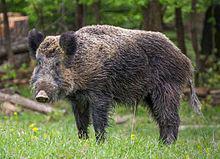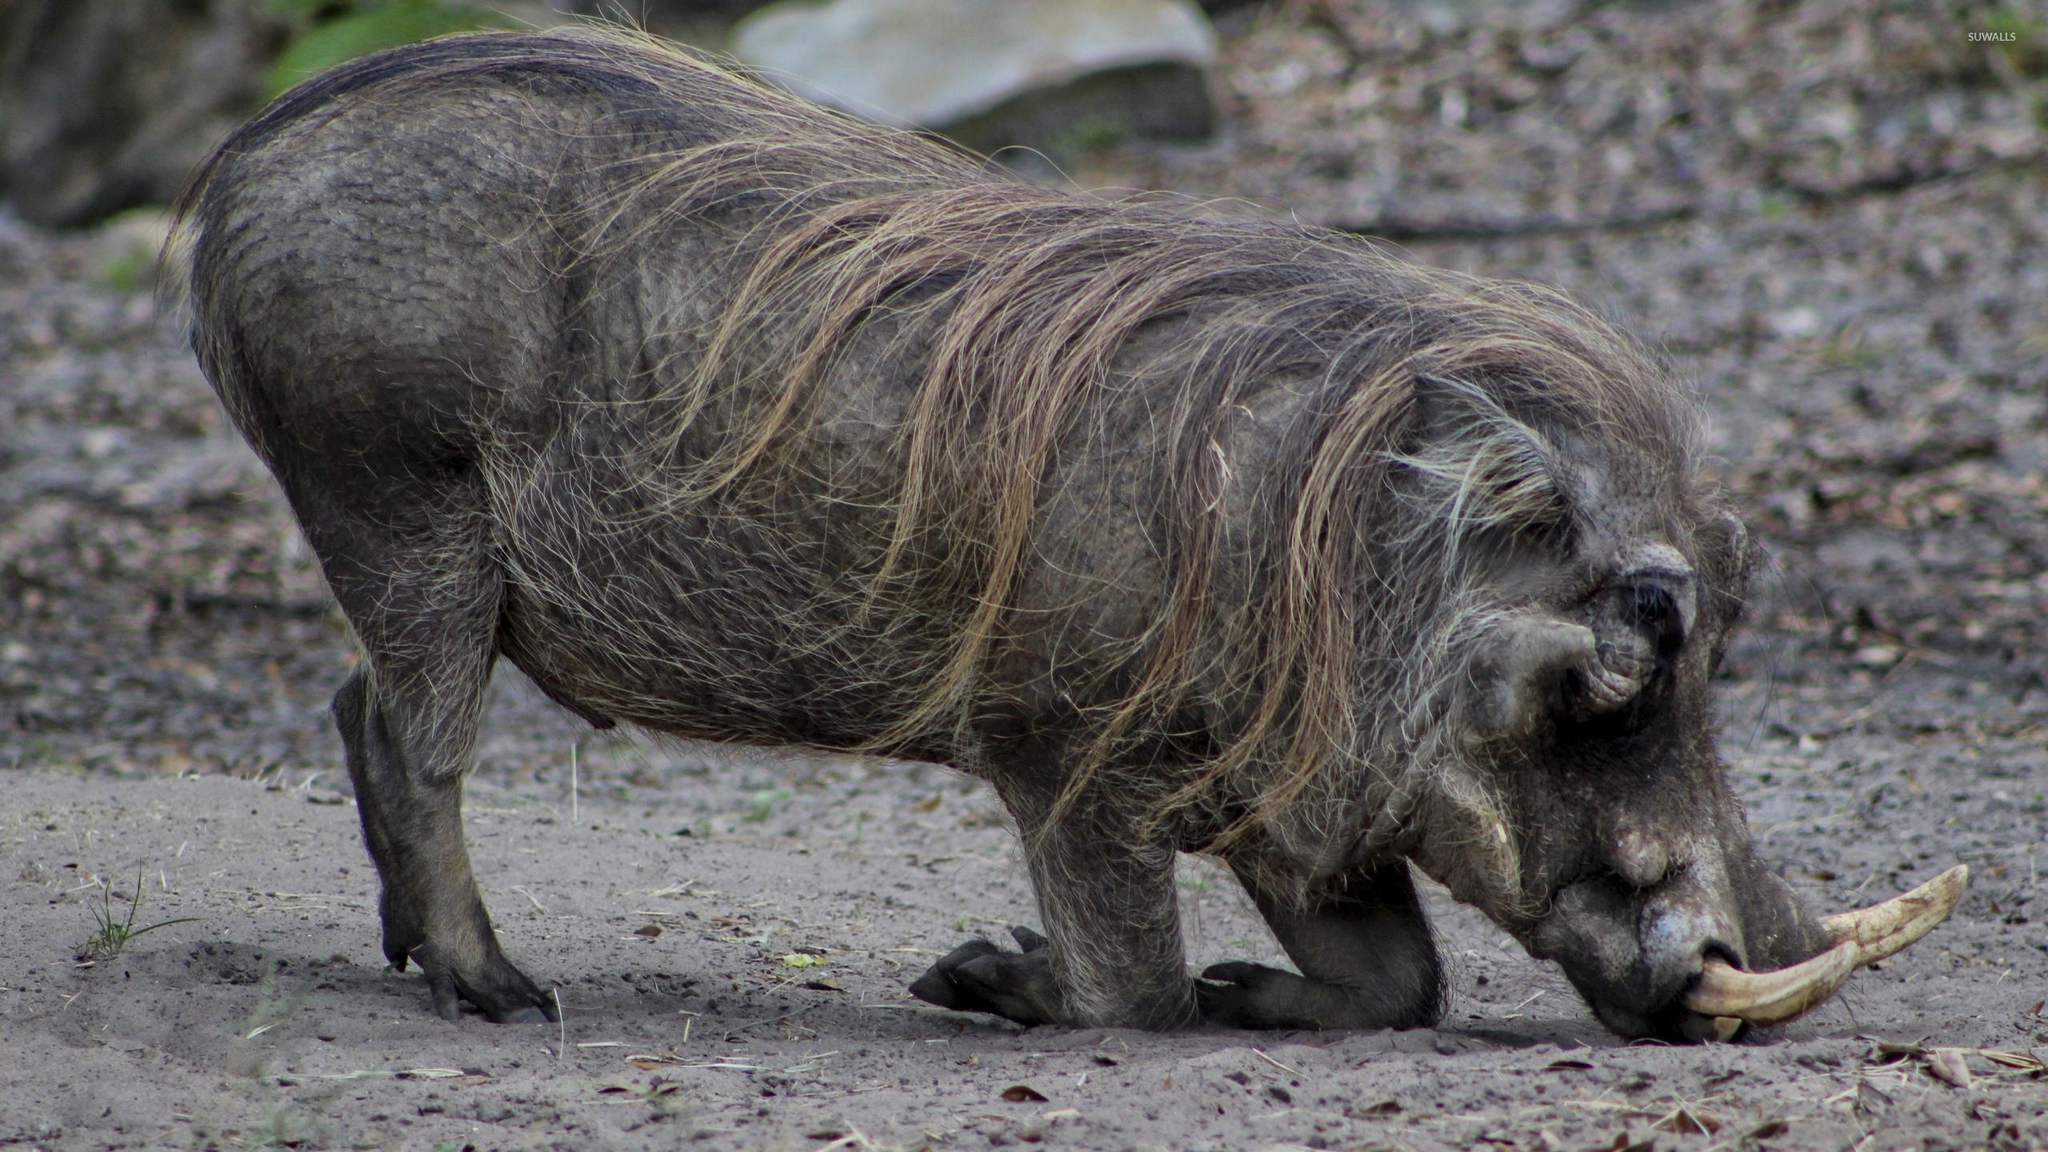The first image is the image on the left, the second image is the image on the right. Analyze the images presented: Is the assertion "Both images feature pigs in the water." valid? Answer yes or no. No. The first image is the image on the left, the second image is the image on the right. For the images shown, is this caption "All of the hogs are in water and some of them are in crystal blue water." true? Answer yes or no. No. 